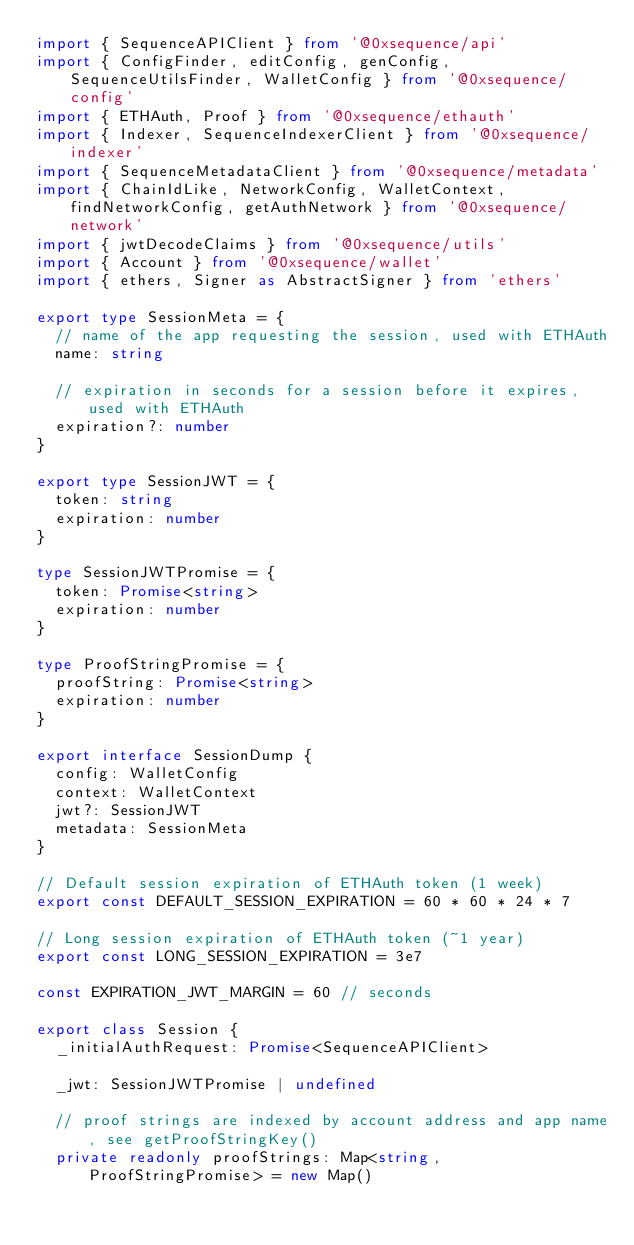<code> <loc_0><loc_0><loc_500><loc_500><_TypeScript_>import { SequenceAPIClient } from '@0xsequence/api'
import { ConfigFinder, editConfig, genConfig, SequenceUtilsFinder, WalletConfig } from '@0xsequence/config'
import { ETHAuth, Proof } from '@0xsequence/ethauth'
import { Indexer, SequenceIndexerClient } from '@0xsequence/indexer'
import { SequenceMetadataClient } from '@0xsequence/metadata'
import { ChainIdLike, NetworkConfig, WalletContext, findNetworkConfig, getAuthNetwork } from '@0xsequence/network'
import { jwtDecodeClaims } from '@0xsequence/utils'
import { Account } from '@0xsequence/wallet'
import { ethers, Signer as AbstractSigner } from 'ethers'

export type SessionMeta = {
  // name of the app requesting the session, used with ETHAuth
  name: string

  // expiration in seconds for a session before it expires, used with ETHAuth
  expiration?: number
}

export type SessionJWT = {
  token: string
  expiration: number
}

type SessionJWTPromise = {
  token: Promise<string>
  expiration: number
}

type ProofStringPromise = {
  proofString: Promise<string>
  expiration: number
}

export interface SessionDump {
  config: WalletConfig
  context: WalletContext
  jwt?: SessionJWT
  metadata: SessionMeta
}

// Default session expiration of ETHAuth token (1 week)
export const DEFAULT_SESSION_EXPIRATION = 60 * 60 * 24 * 7

// Long session expiration of ETHAuth token (~1 year)
export const LONG_SESSION_EXPIRATION = 3e7

const EXPIRATION_JWT_MARGIN = 60 // seconds

export class Session {
  _initialAuthRequest: Promise<SequenceAPIClient>

  _jwt: SessionJWTPromise | undefined

  // proof strings are indexed by account address and app name, see getProofStringKey()
  private readonly proofStrings: Map<string, ProofStringPromise> = new Map()
</code> 